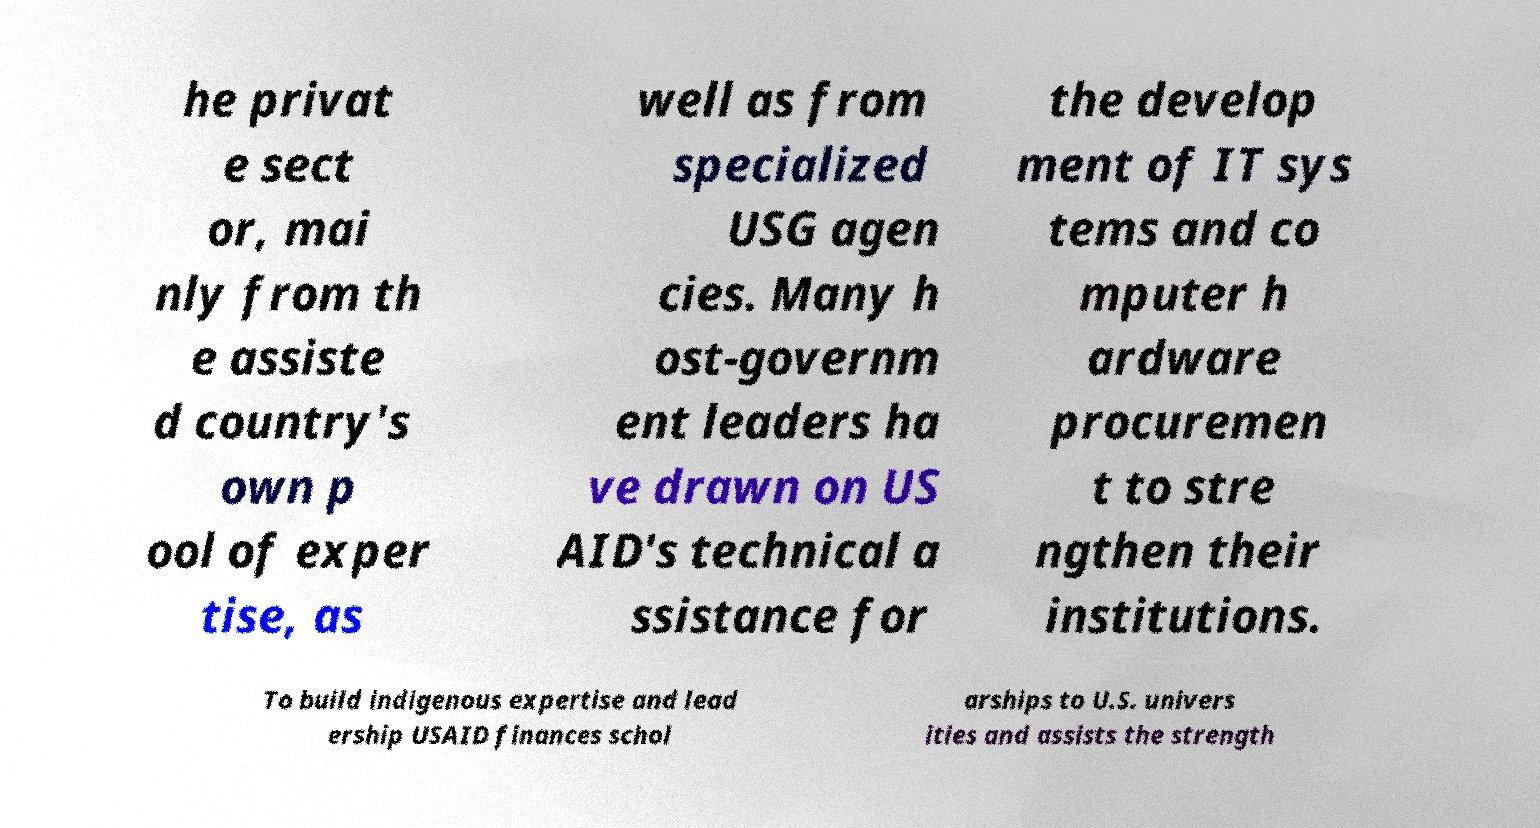There's text embedded in this image that I need extracted. Can you transcribe it verbatim? he privat e sect or, mai nly from th e assiste d country's own p ool of exper tise, as well as from specialized USG agen cies. Many h ost-governm ent leaders ha ve drawn on US AID's technical a ssistance for the develop ment of IT sys tems and co mputer h ardware procuremen t to stre ngthen their institutions. To build indigenous expertise and lead ership USAID finances schol arships to U.S. univers ities and assists the strength 